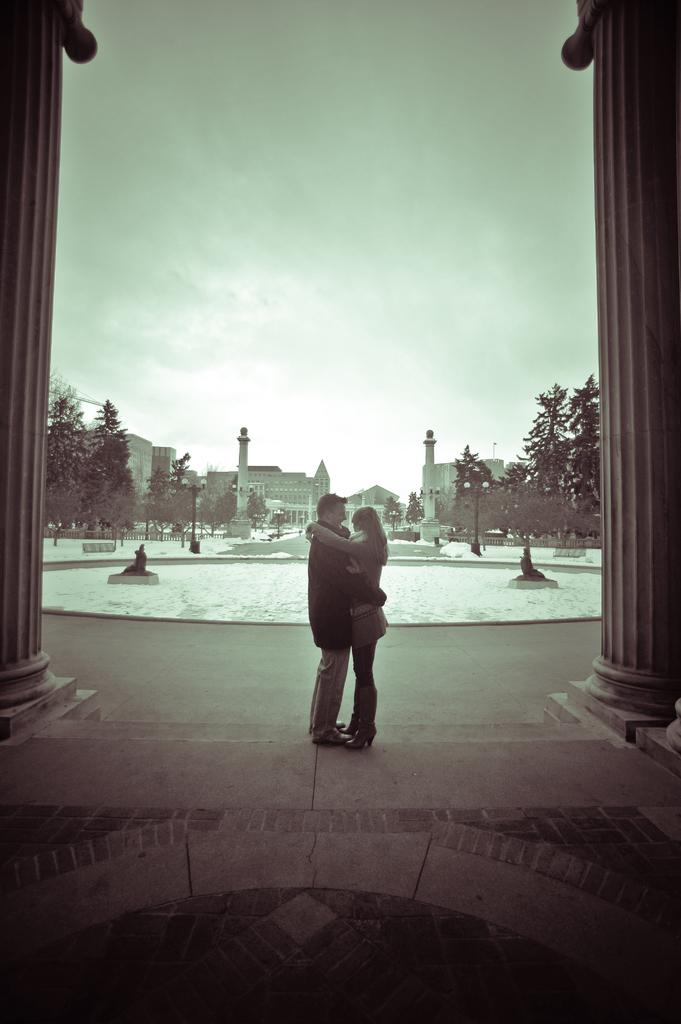What can be seen in the middle of the image? There are buildings and trees in the middle of the image. Are there any people present in the image? Yes, there are two persons standing in the middle of the image. What is visible at the top of the image? The sky is visible at the top of the image. What type of lunch is being served to the cars in the image? There are no cars or lunch present in the image; it features buildings, trees, and two persons. How many trucks are visible in the image? There are no trucks visible in the image. 